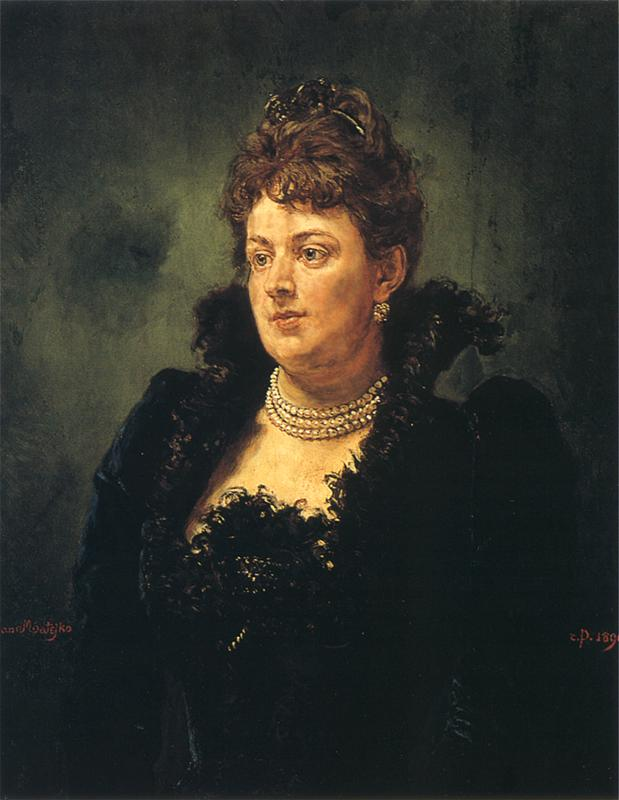Describe the following image. The image is a captivating portrait of a woman, rendered in a style reminiscent of the impressionist era, which emphasizes the fleeting effects of light and color. The subject is depicted in a three-quarter view, her gaze directed towards something beyond the frame, adding an air of mystery to the composition. She is elegantly dressed in a sophisticated black dress adorned with intricate lace details and a ribbon. The dress contrasts beautifully with the pearl necklace and earrings she wears, their soft glow adding a touch of elegance and refinement. The background is a harmonious blend of dark tones of green, black, and brown, which not only serves to highlight the subject but also creates a sense of depth and dimension. The painting is signed and dated in the lower right corner, indicating the artist's pride and connection to this creation, providing a bridge between the viewer and the moment of its completion. Overall, this portrait is a beautiful representation of skilled craftsmanship, capturing the subtleties of light, color, and form. 